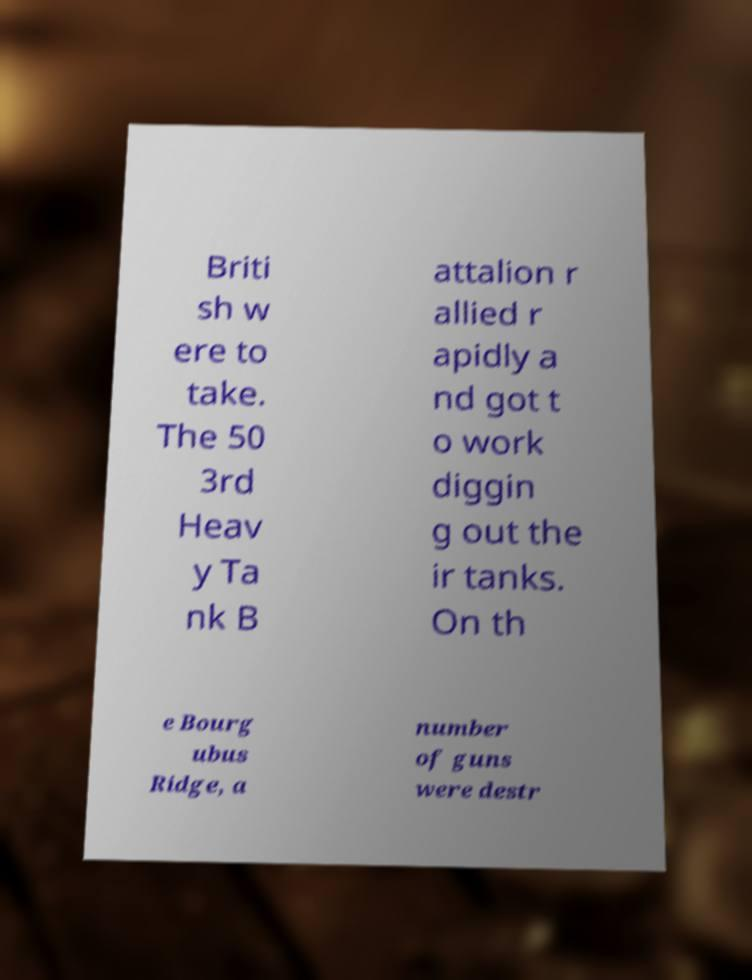Please identify and transcribe the text found in this image. Briti sh w ere to take. The 50 3rd Heav y Ta nk B attalion r allied r apidly a nd got t o work diggin g out the ir tanks. On th e Bourg ubus Ridge, a number of guns were destr 